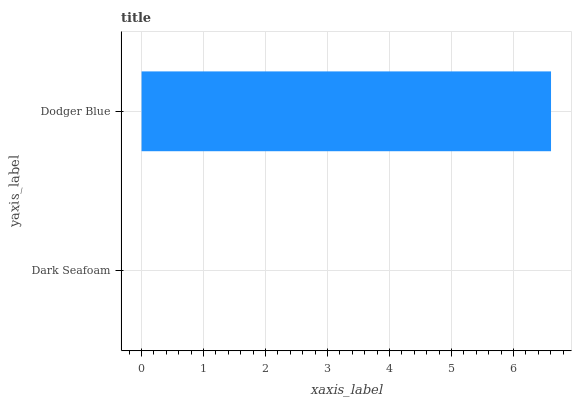Is Dark Seafoam the minimum?
Answer yes or no. Yes. Is Dodger Blue the maximum?
Answer yes or no. Yes. Is Dodger Blue the minimum?
Answer yes or no. No. Is Dodger Blue greater than Dark Seafoam?
Answer yes or no. Yes. Is Dark Seafoam less than Dodger Blue?
Answer yes or no. Yes. Is Dark Seafoam greater than Dodger Blue?
Answer yes or no. No. Is Dodger Blue less than Dark Seafoam?
Answer yes or no. No. Is Dodger Blue the high median?
Answer yes or no. Yes. Is Dark Seafoam the low median?
Answer yes or no. Yes. Is Dark Seafoam the high median?
Answer yes or no. No. Is Dodger Blue the low median?
Answer yes or no. No. 